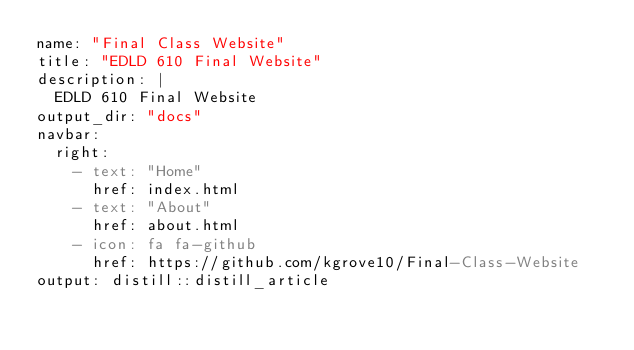Convert code to text. <code><loc_0><loc_0><loc_500><loc_500><_YAML_>name: "Final Class Website"
title: "EDLD 610 Final Website"
description: |
  EDLD 610 Final Website
output_dir: "docs"
navbar:
  right:
    - text: "Home"
      href: index.html
    - text: "About"
      href: about.html
    - icon: fa fa-github
      href: https://github.com/kgrove10/Final-Class-Website
output: distill::distill_article
</code> 